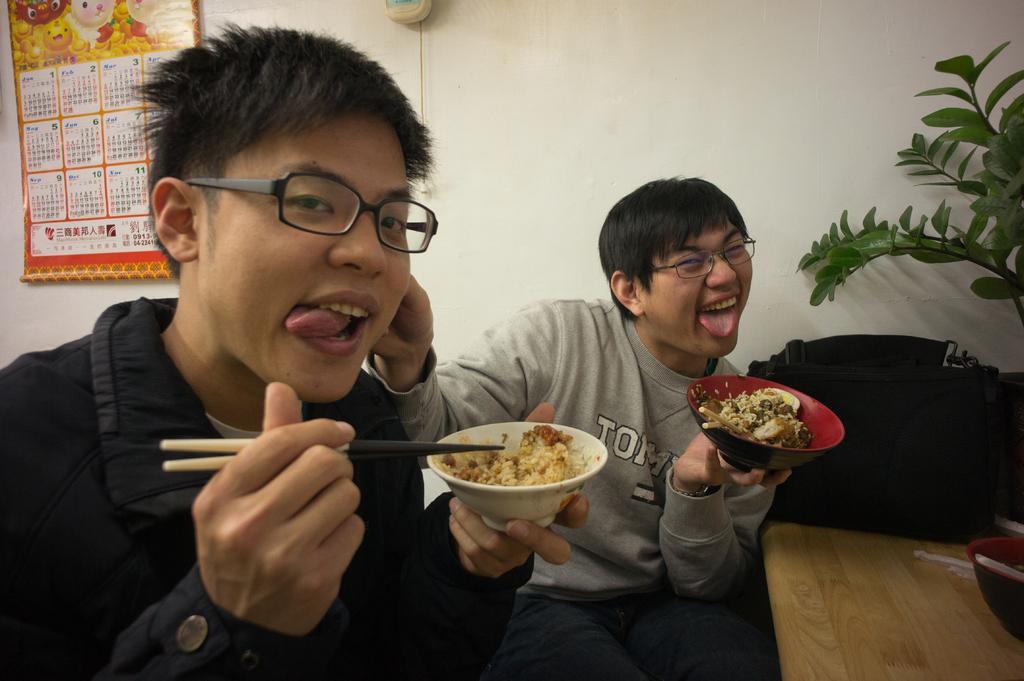Please provide a concise description of this image. In this image, on the right side there is a table which is in yellow color, There are two boys sitting and holding a bowls which contains food, In the background there is a plant which is in green color, There wall which is in white color, In the left side of the image there is a calendar which is in yellow color. 